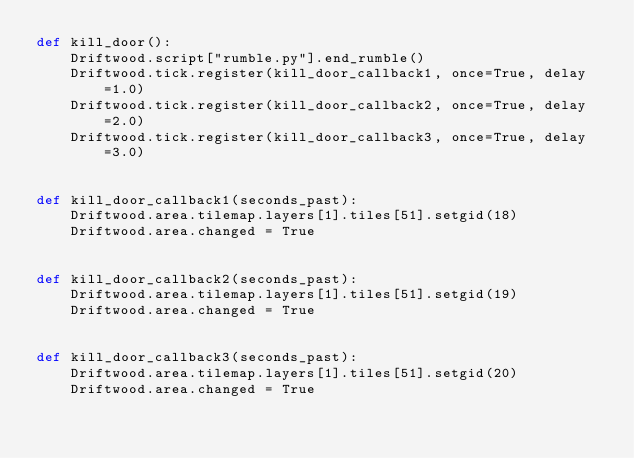<code> <loc_0><loc_0><loc_500><loc_500><_Python_>def kill_door():
    Driftwood.script["rumble.py"].end_rumble()
    Driftwood.tick.register(kill_door_callback1, once=True, delay=1.0)
    Driftwood.tick.register(kill_door_callback2, once=True, delay=2.0)
    Driftwood.tick.register(kill_door_callback3, once=True, delay=3.0)


def kill_door_callback1(seconds_past):
    Driftwood.area.tilemap.layers[1].tiles[51].setgid(18)
    Driftwood.area.changed = True


def kill_door_callback2(seconds_past):
    Driftwood.area.tilemap.layers[1].tiles[51].setgid(19)
    Driftwood.area.changed = True


def kill_door_callback3(seconds_past):
    Driftwood.area.tilemap.layers[1].tiles[51].setgid(20)
    Driftwood.area.changed = True

</code> 